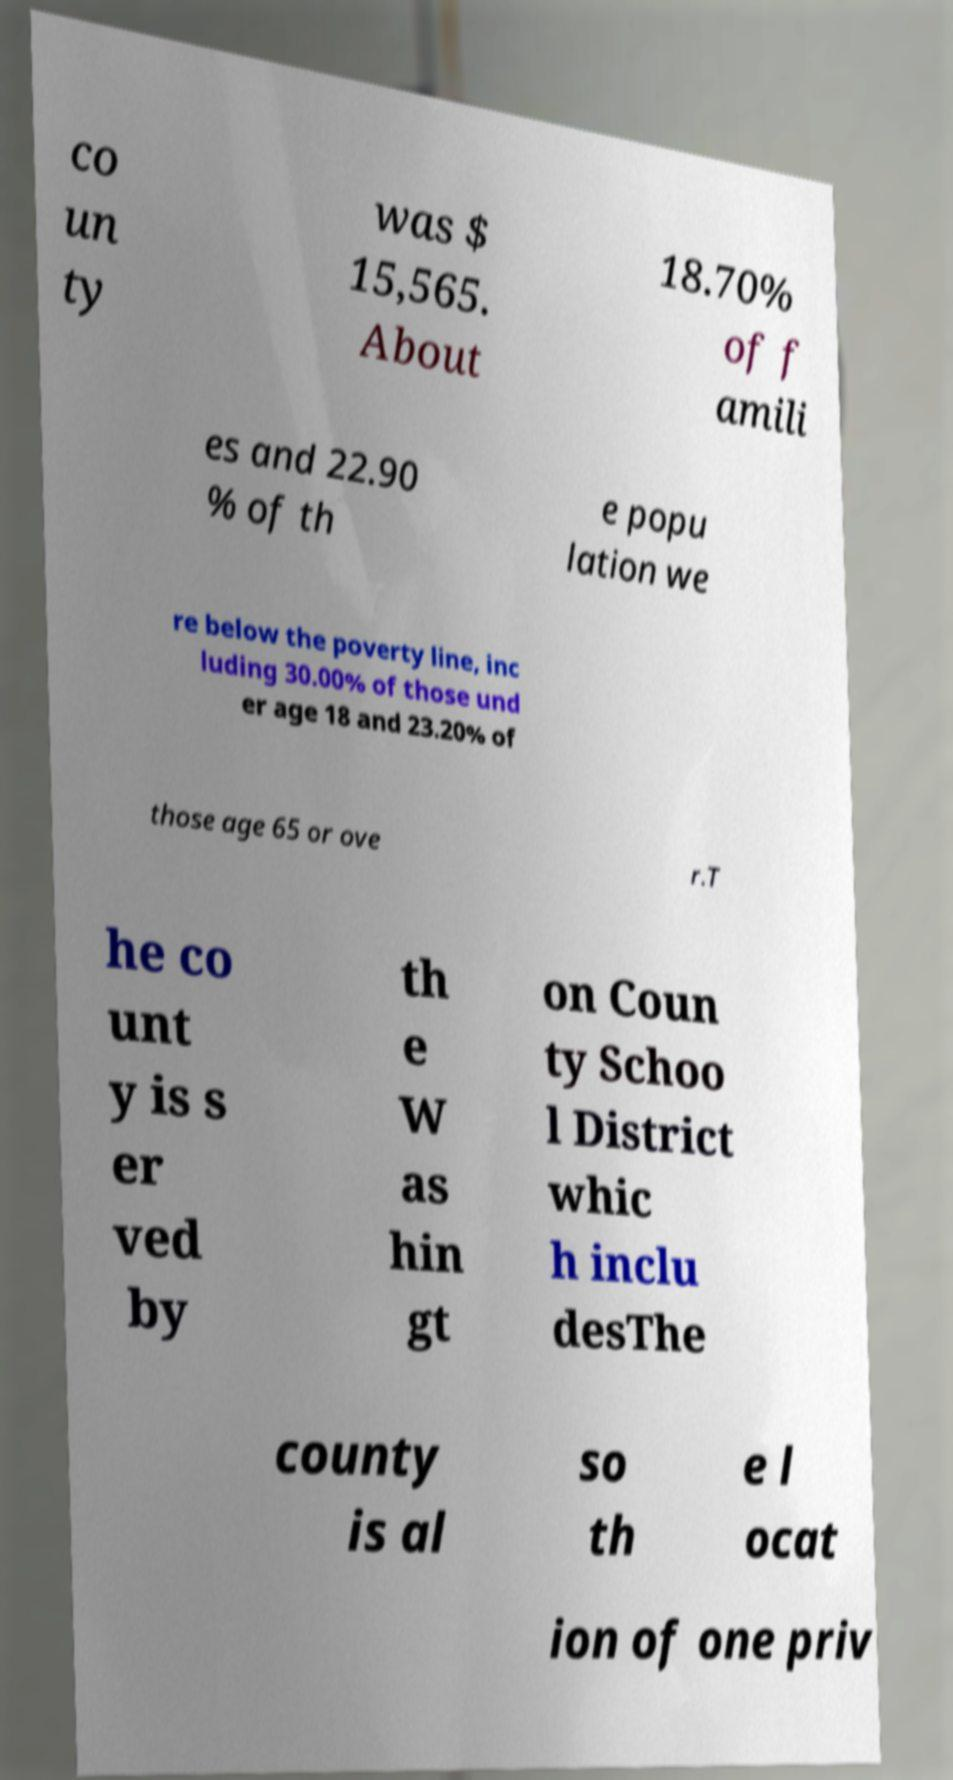What messages or text are displayed in this image? I need them in a readable, typed format. co un ty was $ 15,565. About 18.70% of f amili es and 22.90 % of th e popu lation we re below the poverty line, inc luding 30.00% of those und er age 18 and 23.20% of those age 65 or ove r.T he co unt y is s er ved by th e W as hin gt on Coun ty Schoo l District whic h inclu desThe county is al so th e l ocat ion of one priv 